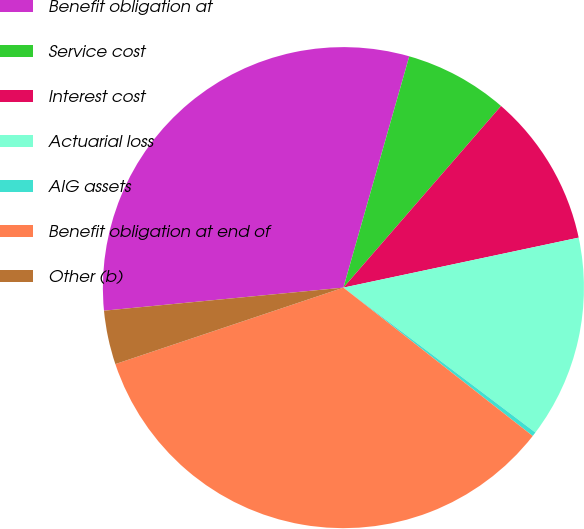Convert chart. <chart><loc_0><loc_0><loc_500><loc_500><pie_chart><fcel>Benefit obligation at<fcel>Service cost<fcel>Interest cost<fcel>Actuarial loss<fcel>AIG assets<fcel>Benefit obligation at end of<fcel>Other (b)<nl><fcel>30.94%<fcel>6.96%<fcel>10.29%<fcel>13.62%<fcel>0.29%<fcel>34.27%<fcel>3.62%<nl></chart> 